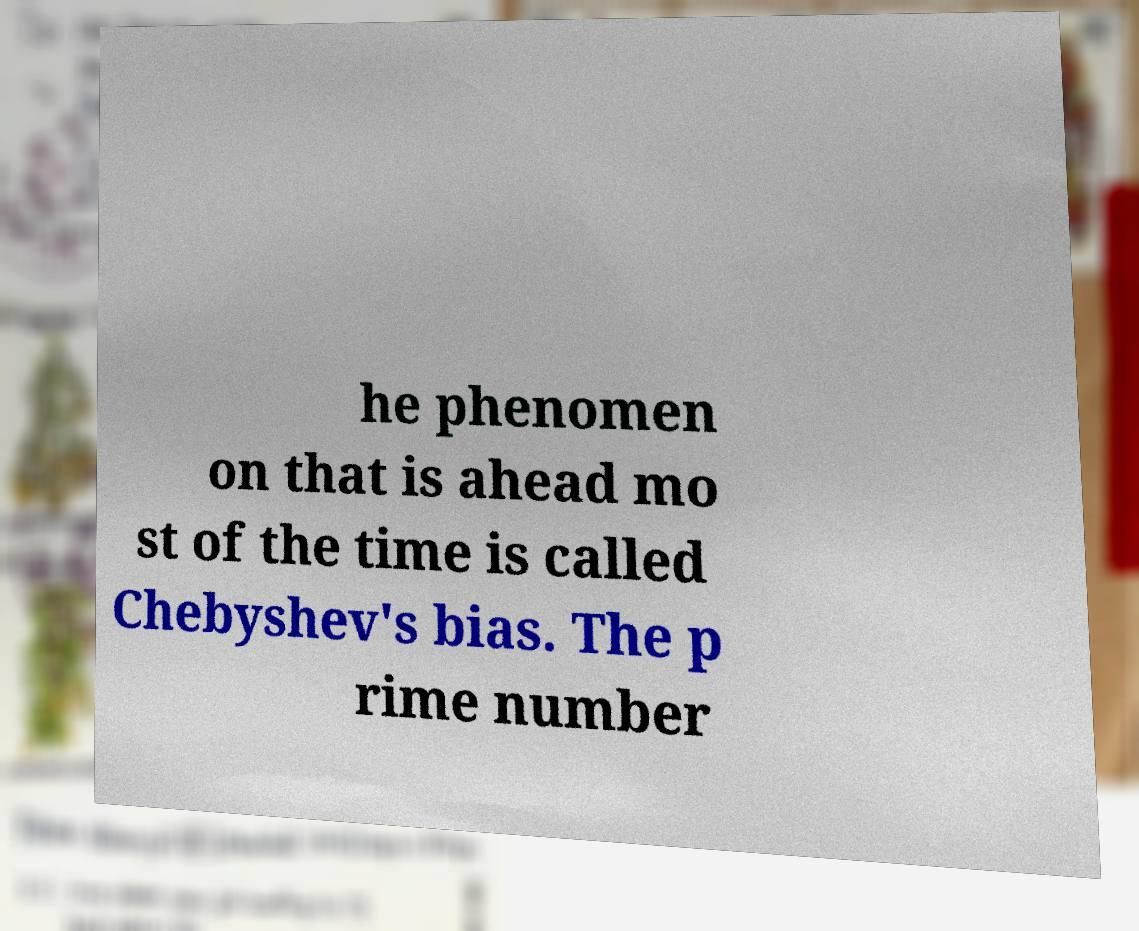What messages or text are displayed in this image? I need them in a readable, typed format. he phenomen on that is ahead mo st of the time is called Chebyshev's bias. The p rime number 